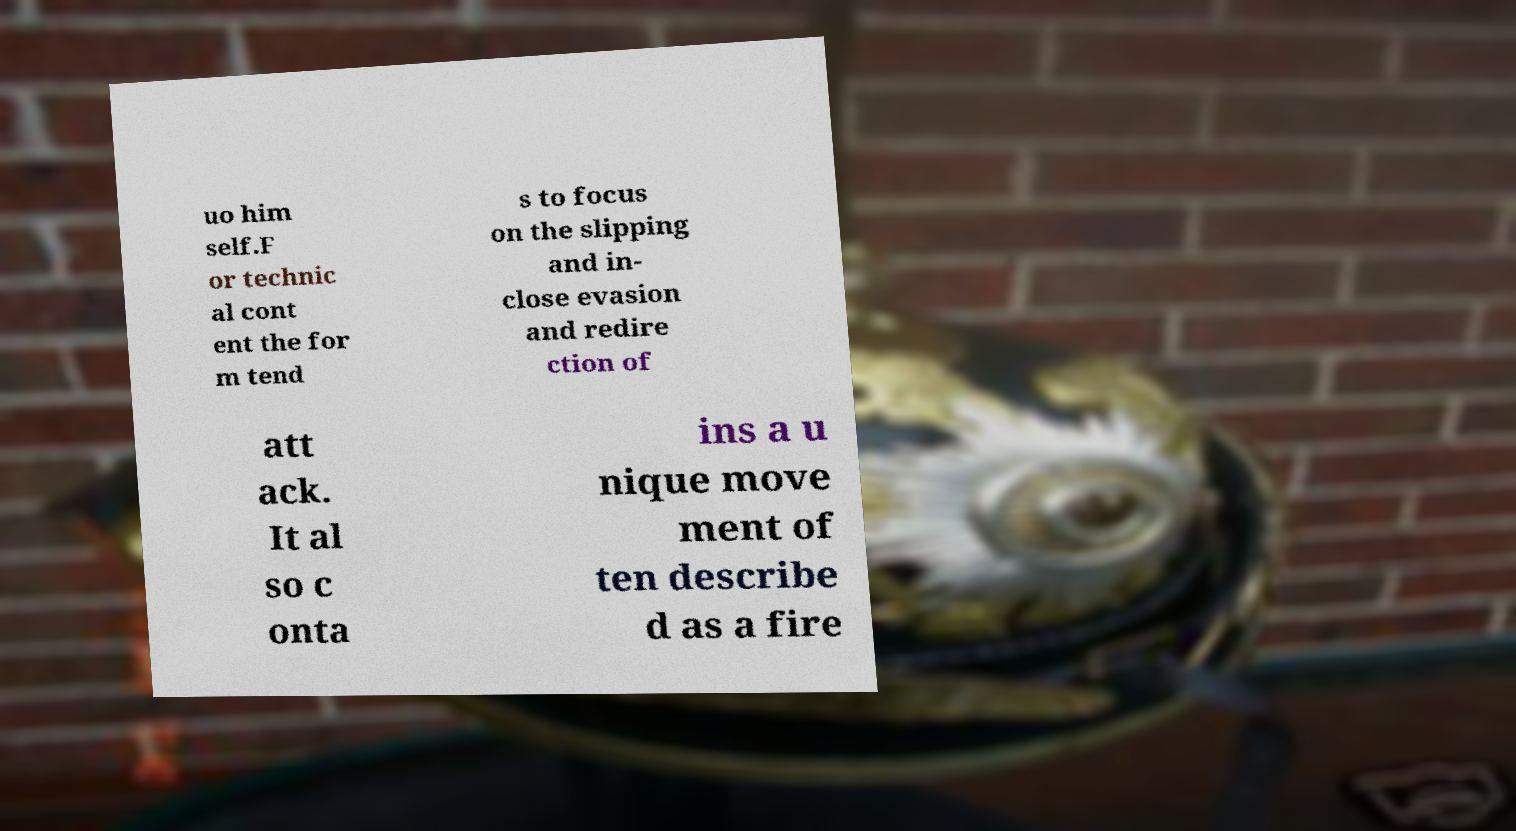What messages or text are displayed in this image? I need them in a readable, typed format. uo him self.F or technic al cont ent the for m tend s to focus on the slipping and in- close evasion and redire ction of att ack. It al so c onta ins a u nique move ment of ten describe d as a fire 